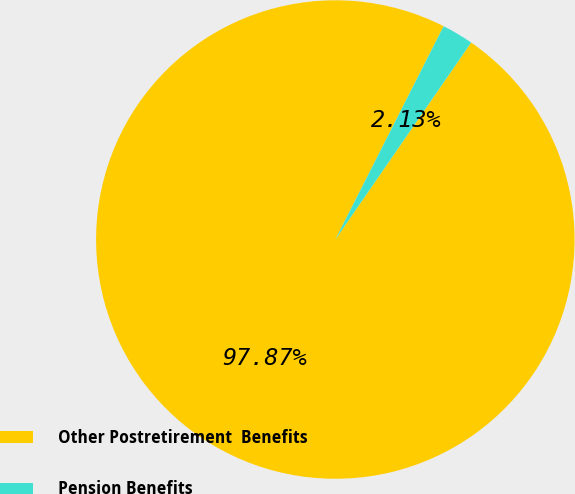Convert chart. <chart><loc_0><loc_0><loc_500><loc_500><pie_chart><fcel>Other Postretirement  Benefits<fcel>Pension Benefits<nl><fcel>97.87%<fcel>2.13%<nl></chart> 